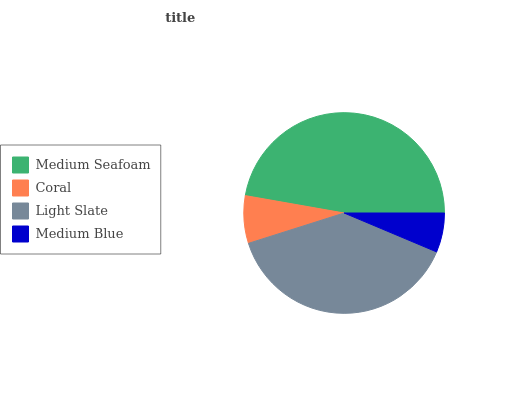Is Medium Blue the minimum?
Answer yes or no. Yes. Is Medium Seafoam the maximum?
Answer yes or no. Yes. Is Coral the minimum?
Answer yes or no. No. Is Coral the maximum?
Answer yes or no. No. Is Medium Seafoam greater than Coral?
Answer yes or no. Yes. Is Coral less than Medium Seafoam?
Answer yes or no. Yes. Is Coral greater than Medium Seafoam?
Answer yes or no. No. Is Medium Seafoam less than Coral?
Answer yes or no. No. Is Light Slate the high median?
Answer yes or no. Yes. Is Coral the low median?
Answer yes or no. Yes. Is Medium Seafoam the high median?
Answer yes or no. No. Is Medium Seafoam the low median?
Answer yes or no. No. 